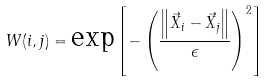Convert formula to latex. <formula><loc_0><loc_0><loc_500><loc_500>W ( i , j ) = \text {exp} \left [ - \left ( \frac { \left \| \vec { X } _ { i } - \vec { X } _ { j } \right \| } { \epsilon } \right ) ^ { 2 } \right ]</formula> 